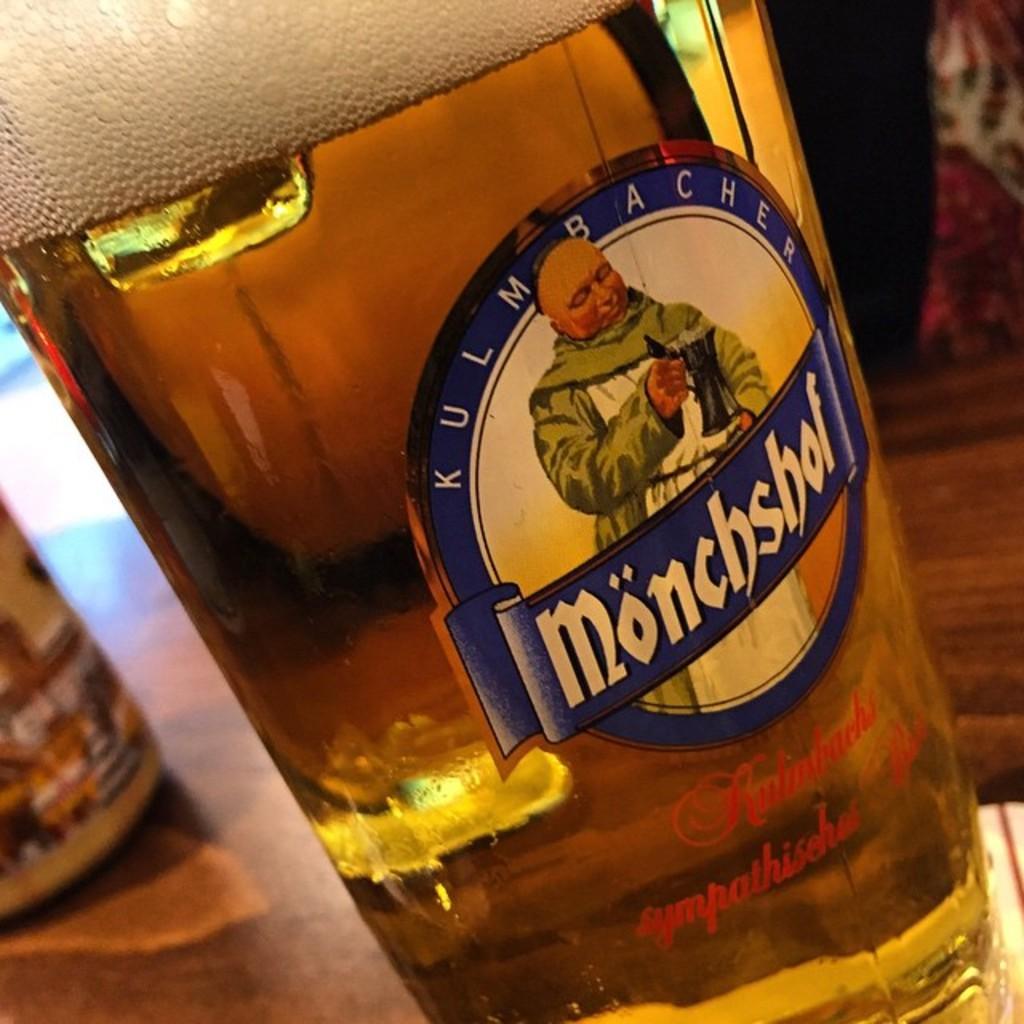Describe this image in one or two sentences. In this picture we can see a bottle. 